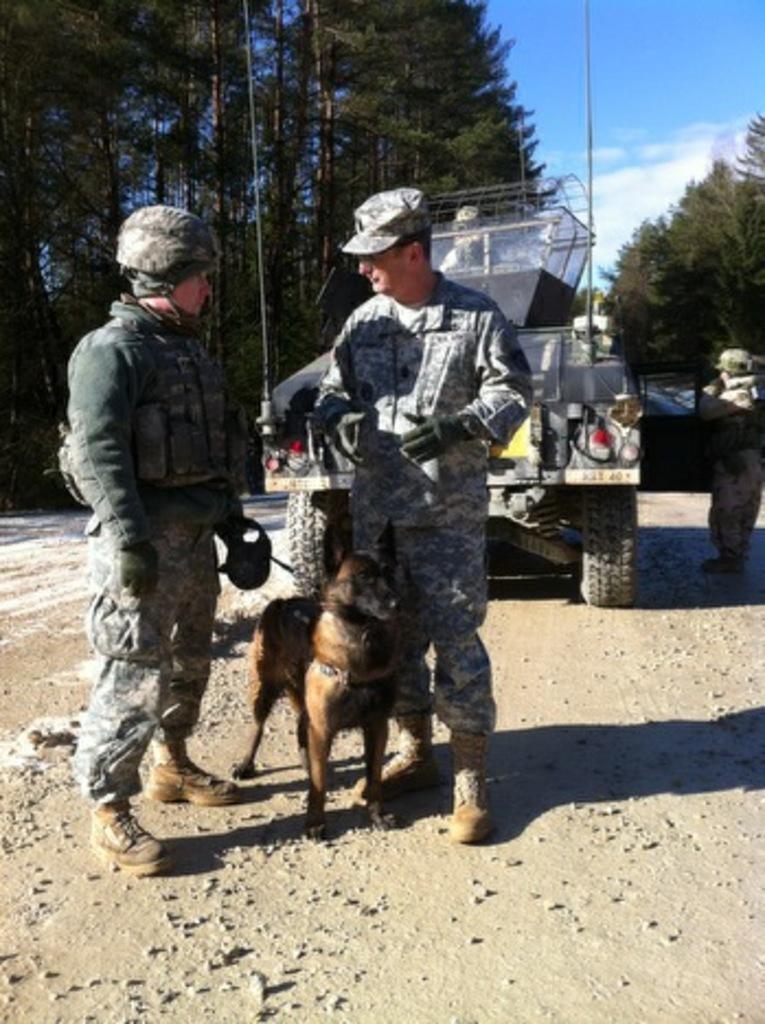Describe this image in one or two sentences. In the image there are two mens in middle there is a dog. In background we can see a van,trees and sky is on top. 